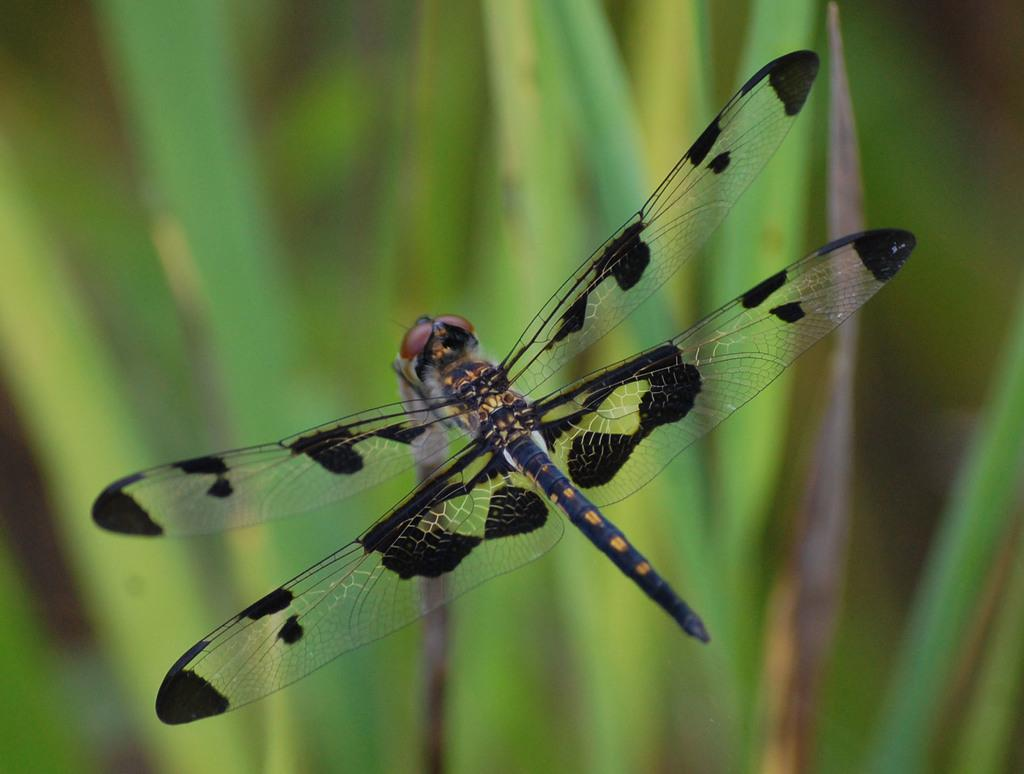What is located in the foreground of the image? There is a fly in the foreground of the image. What can be seen in the background of the image? There are plants in the background of the image. What type of fiction is the fly reading in the image? There is no indication in the image that the fly is reading any fiction, as flies do not have the ability to read. 